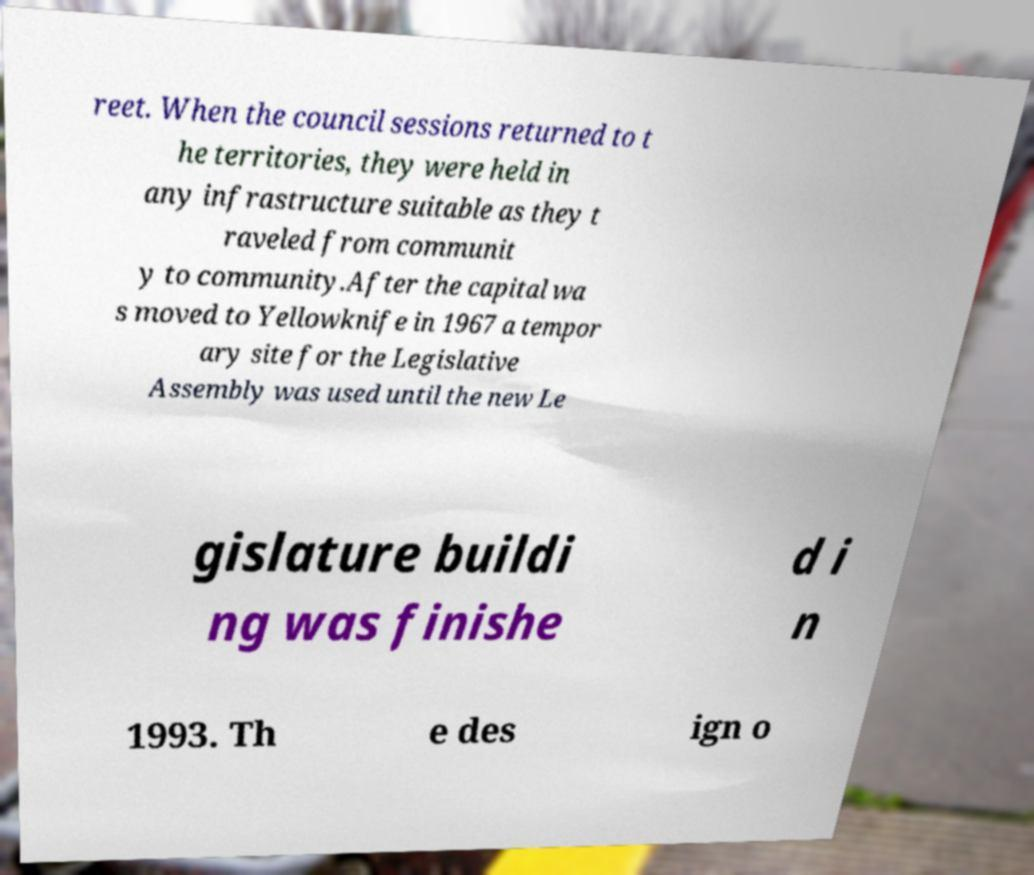What messages or text are displayed in this image? I need them in a readable, typed format. reet. When the council sessions returned to t he territories, they were held in any infrastructure suitable as they t raveled from communit y to community.After the capital wa s moved to Yellowknife in 1967 a tempor ary site for the Legislative Assembly was used until the new Le gislature buildi ng was finishe d i n 1993. Th e des ign o 